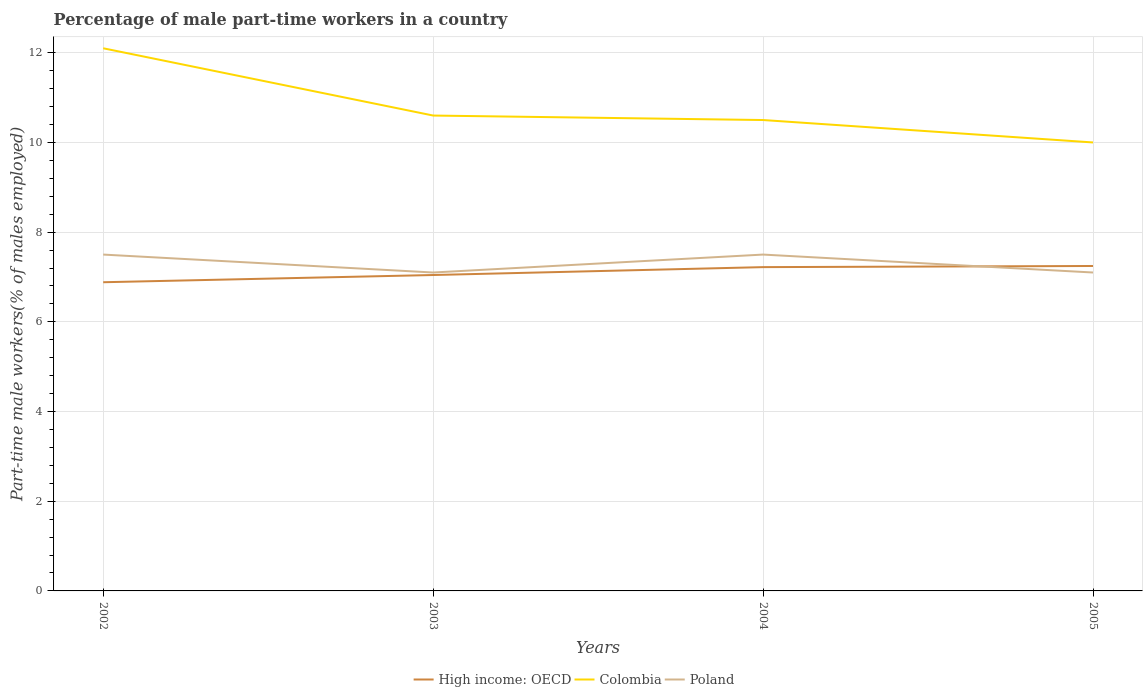Is the number of lines equal to the number of legend labels?
Your answer should be compact. Yes. Across all years, what is the maximum percentage of male part-time workers in Poland?
Offer a terse response. 7.1. What is the total percentage of male part-time workers in Poland in the graph?
Your response must be concise. 0.4. What is the difference between the highest and the second highest percentage of male part-time workers in High income: OECD?
Keep it short and to the point. 0.36. How many years are there in the graph?
Your answer should be compact. 4. What is the difference between two consecutive major ticks on the Y-axis?
Make the answer very short. 2. Are the values on the major ticks of Y-axis written in scientific E-notation?
Provide a succinct answer. No. Where does the legend appear in the graph?
Ensure brevity in your answer.  Bottom center. How many legend labels are there?
Offer a very short reply. 3. How are the legend labels stacked?
Your response must be concise. Horizontal. What is the title of the graph?
Offer a terse response. Percentage of male part-time workers in a country. What is the label or title of the Y-axis?
Ensure brevity in your answer.  Part-time male workers(% of males employed). What is the Part-time male workers(% of males employed) of High income: OECD in 2002?
Make the answer very short. 6.88. What is the Part-time male workers(% of males employed) of Colombia in 2002?
Your response must be concise. 12.1. What is the Part-time male workers(% of males employed) in High income: OECD in 2003?
Ensure brevity in your answer.  7.04. What is the Part-time male workers(% of males employed) in Colombia in 2003?
Provide a succinct answer. 10.6. What is the Part-time male workers(% of males employed) in Poland in 2003?
Provide a succinct answer. 7.1. What is the Part-time male workers(% of males employed) in High income: OECD in 2004?
Offer a very short reply. 7.22. What is the Part-time male workers(% of males employed) of High income: OECD in 2005?
Keep it short and to the point. 7.25. What is the Part-time male workers(% of males employed) of Poland in 2005?
Provide a short and direct response. 7.1. Across all years, what is the maximum Part-time male workers(% of males employed) in High income: OECD?
Keep it short and to the point. 7.25. Across all years, what is the maximum Part-time male workers(% of males employed) in Colombia?
Offer a very short reply. 12.1. Across all years, what is the minimum Part-time male workers(% of males employed) of High income: OECD?
Your response must be concise. 6.88. Across all years, what is the minimum Part-time male workers(% of males employed) in Poland?
Your response must be concise. 7.1. What is the total Part-time male workers(% of males employed) in High income: OECD in the graph?
Offer a terse response. 28.39. What is the total Part-time male workers(% of males employed) in Colombia in the graph?
Offer a terse response. 43.2. What is the total Part-time male workers(% of males employed) of Poland in the graph?
Provide a succinct answer. 29.2. What is the difference between the Part-time male workers(% of males employed) in High income: OECD in 2002 and that in 2003?
Offer a terse response. -0.16. What is the difference between the Part-time male workers(% of males employed) in Poland in 2002 and that in 2003?
Provide a short and direct response. 0.4. What is the difference between the Part-time male workers(% of males employed) in High income: OECD in 2002 and that in 2004?
Your response must be concise. -0.34. What is the difference between the Part-time male workers(% of males employed) in Poland in 2002 and that in 2004?
Offer a terse response. 0. What is the difference between the Part-time male workers(% of males employed) of High income: OECD in 2002 and that in 2005?
Your answer should be very brief. -0.36. What is the difference between the Part-time male workers(% of males employed) in Poland in 2002 and that in 2005?
Make the answer very short. 0.4. What is the difference between the Part-time male workers(% of males employed) of High income: OECD in 2003 and that in 2004?
Your response must be concise. -0.18. What is the difference between the Part-time male workers(% of males employed) of Colombia in 2003 and that in 2004?
Make the answer very short. 0.1. What is the difference between the Part-time male workers(% of males employed) of High income: OECD in 2003 and that in 2005?
Your answer should be compact. -0.2. What is the difference between the Part-time male workers(% of males employed) of Colombia in 2003 and that in 2005?
Keep it short and to the point. 0.6. What is the difference between the Part-time male workers(% of males employed) in Poland in 2003 and that in 2005?
Offer a very short reply. 0. What is the difference between the Part-time male workers(% of males employed) in High income: OECD in 2004 and that in 2005?
Offer a terse response. -0.03. What is the difference between the Part-time male workers(% of males employed) of High income: OECD in 2002 and the Part-time male workers(% of males employed) of Colombia in 2003?
Keep it short and to the point. -3.72. What is the difference between the Part-time male workers(% of males employed) in High income: OECD in 2002 and the Part-time male workers(% of males employed) in Poland in 2003?
Your answer should be compact. -0.22. What is the difference between the Part-time male workers(% of males employed) of High income: OECD in 2002 and the Part-time male workers(% of males employed) of Colombia in 2004?
Offer a very short reply. -3.62. What is the difference between the Part-time male workers(% of males employed) in High income: OECD in 2002 and the Part-time male workers(% of males employed) in Poland in 2004?
Provide a short and direct response. -0.62. What is the difference between the Part-time male workers(% of males employed) in Colombia in 2002 and the Part-time male workers(% of males employed) in Poland in 2004?
Your answer should be very brief. 4.6. What is the difference between the Part-time male workers(% of males employed) of High income: OECD in 2002 and the Part-time male workers(% of males employed) of Colombia in 2005?
Offer a terse response. -3.12. What is the difference between the Part-time male workers(% of males employed) of High income: OECD in 2002 and the Part-time male workers(% of males employed) of Poland in 2005?
Provide a short and direct response. -0.22. What is the difference between the Part-time male workers(% of males employed) in Colombia in 2002 and the Part-time male workers(% of males employed) in Poland in 2005?
Your answer should be compact. 5. What is the difference between the Part-time male workers(% of males employed) of High income: OECD in 2003 and the Part-time male workers(% of males employed) of Colombia in 2004?
Your response must be concise. -3.46. What is the difference between the Part-time male workers(% of males employed) of High income: OECD in 2003 and the Part-time male workers(% of males employed) of Poland in 2004?
Your answer should be very brief. -0.46. What is the difference between the Part-time male workers(% of males employed) of Colombia in 2003 and the Part-time male workers(% of males employed) of Poland in 2004?
Offer a terse response. 3.1. What is the difference between the Part-time male workers(% of males employed) of High income: OECD in 2003 and the Part-time male workers(% of males employed) of Colombia in 2005?
Offer a very short reply. -2.96. What is the difference between the Part-time male workers(% of males employed) in High income: OECD in 2003 and the Part-time male workers(% of males employed) in Poland in 2005?
Your answer should be very brief. -0.06. What is the difference between the Part-time male workers(% of males employed) of Colombia in 2003 and the Part-time male workers(% of males employed) of Poland in 2005?
Provide a succinct answer. 3.5. What is the difference between the Part-time male workers(% of males employed) in High income: OECD in 2004 and the Part-time male workers(% of males employed) in Colombia in 2005?
Your response must be concise. -2.78. What is the difference between the Part-time male workers(% of males employed) of High income: OECD in 2004 and the Part-time male workers(% of males employed) of Poland in 2005?
Ensure brevity in your answer.  0.12. What is the average Part-time male workers(% of males employed) in High income: OECD per year?
Offer a very short reply. 7.1. What is the average Part-time male workers(% of males employed) in Poland per year?
Keep it short and to the point. 7.3. In the year 2002, what is the difference between the Part-time male workers(% of males employed) of High income: OECD and Part-time male workers(% of males employed) of Colombia?
Your answer should be very brief. -5.22. In the year 2002, what is the difference between the Part-time male workers(% of males employed) of High income: OECD and Part-time male workers(% of males employed) of Poland?
Ensure brevity in your answer.  -0.62. In the year 2003, what is the difference between the Part-time male workers(% of males employed) in High income: OECD and Part-time male workers(% of males employed) in Colombia?
Ensure brevity in your answer.  -3.56. In the year 2003, what is the difference between the Part-time male workers(% of males employed) of High income: OECD and Part-time male workers(% of males employed) of Poland?
Make the answer very short. -0.06. In the year 2003, what is the difference between the Part-time male workers(% of males employed) in Colombia and Part-time male workers(% of males employed) in Poland?
Provide a succinct answer. 3.5. In the year 2004, what is the difference between the Part-time male workers(% of males employed) of High income: OECD and Part-time male workers(% of males employed) of Colombia?
Give a very brief answer. -3.28. In the year 2004, what is the difference between the Part-time male workers(% of males employed) in High income: OECD and Part-time male workers(% of males employed) in Poland?
Give a very brief answer. -0.28. In the year 2005, what is the difference between the Part-time male workers(% of males employed) in High income: OECD and Part-time male workers(% of males employed) in Colombia?
Make the answer very short. -2.75. In the year 2005, what is the difference between the Part-time male workers(% of males employed) in High income: OECD and Part-time male workers(% of males employed) in Poland?
Your response must be concise. 0.15. In the year 2005, what is the difference between the Part-time male workers(% of males employed) of Colombia and Part-time male workers(% of males employed) of Poland?
Your answer should be compact. 2.9. What is the ratio of the Part-time male workers(% of males employed) of High income: OECD in 2002 to that in 2003?
Your response must be concise. 0.98. What is the ratio of the Part-time male workers(% of males employed) of Colombia in 2002 to that in 2003?
Your answer should be compact. 1.14. What is the ratio of the Part-time male workers(% of males employed) of Poland in 2002 to that in 2003?
Offer a terse response. 1.06. What is the ratio of the Part-time male workers(% of males employed) of High income: OECD in 2002 to that in 2004?
Your answer should be very brief. 0.95. What is the ratio of the Part-time male workers(% of males employed) in Colombia in 2002 to that in 2004?
Provide a short and direct response. 1.15. What is the ratio of the Part-time male workers(% of males employed) in Colombia in 2002 to that in 2005?
Ensure brevity in your answer.  1.21. What is the ratio of the Part-time male workers(% of males employed) of Poland in 2002 to that in 2005?
Your answer should be compact. 1.06. What is the ratio of the Part-time male workers(% of males employed) in High income: OECD in 2003 to that in 2004?
Your response must be concise. 0.98. What is the ratio of the Part-time male workers(% of males employed) in Colombia in 2003 to that in 2004?
Your response must be concise. 1.01. What is the ratio of the Part-time male workers(% of males employed) in Poland in 2003 to that in 2004?
Provide a short and direct response. 0.95. What is the ratio of the Part-time male workers(% of males employed) in High income: OECD in 2003 to that in 2005?
Your response must be concise. 0.97. What is the ratio of the Part-time male workers(% of males employed) in Colombia in 2003 to that in 2005?
Provide a succinct answer. 1.06. What is the ratio of the Part-time male workers(% of males employed) in High income: OECD in 2004 to that in 2005?
Provide a succinct answer. 1. What is the ratio of the Part-time male workers(% of males employed) in Poland in 2004 to that in 2005?
Keep it short and to the point. 1.06. What is the difference between the highest and the second highest Part-time male workers(% of males employed) in High income: OECD?
Your answer should be compact. 0.03. What is the difference between the highest and the second highest Part-time male workers(% of males employed) in Poland?
Keep it short and to the point. 0. What is the difference between the highest and the lowest Part-time male workers(% of males employed) in High income: OECD?
Your answer should be very brief. 0.36. What is the difference between the highest and the lowest Part-time male workers(% of males employed) in Colombia?
Your answer should be very brief. 2.1. 